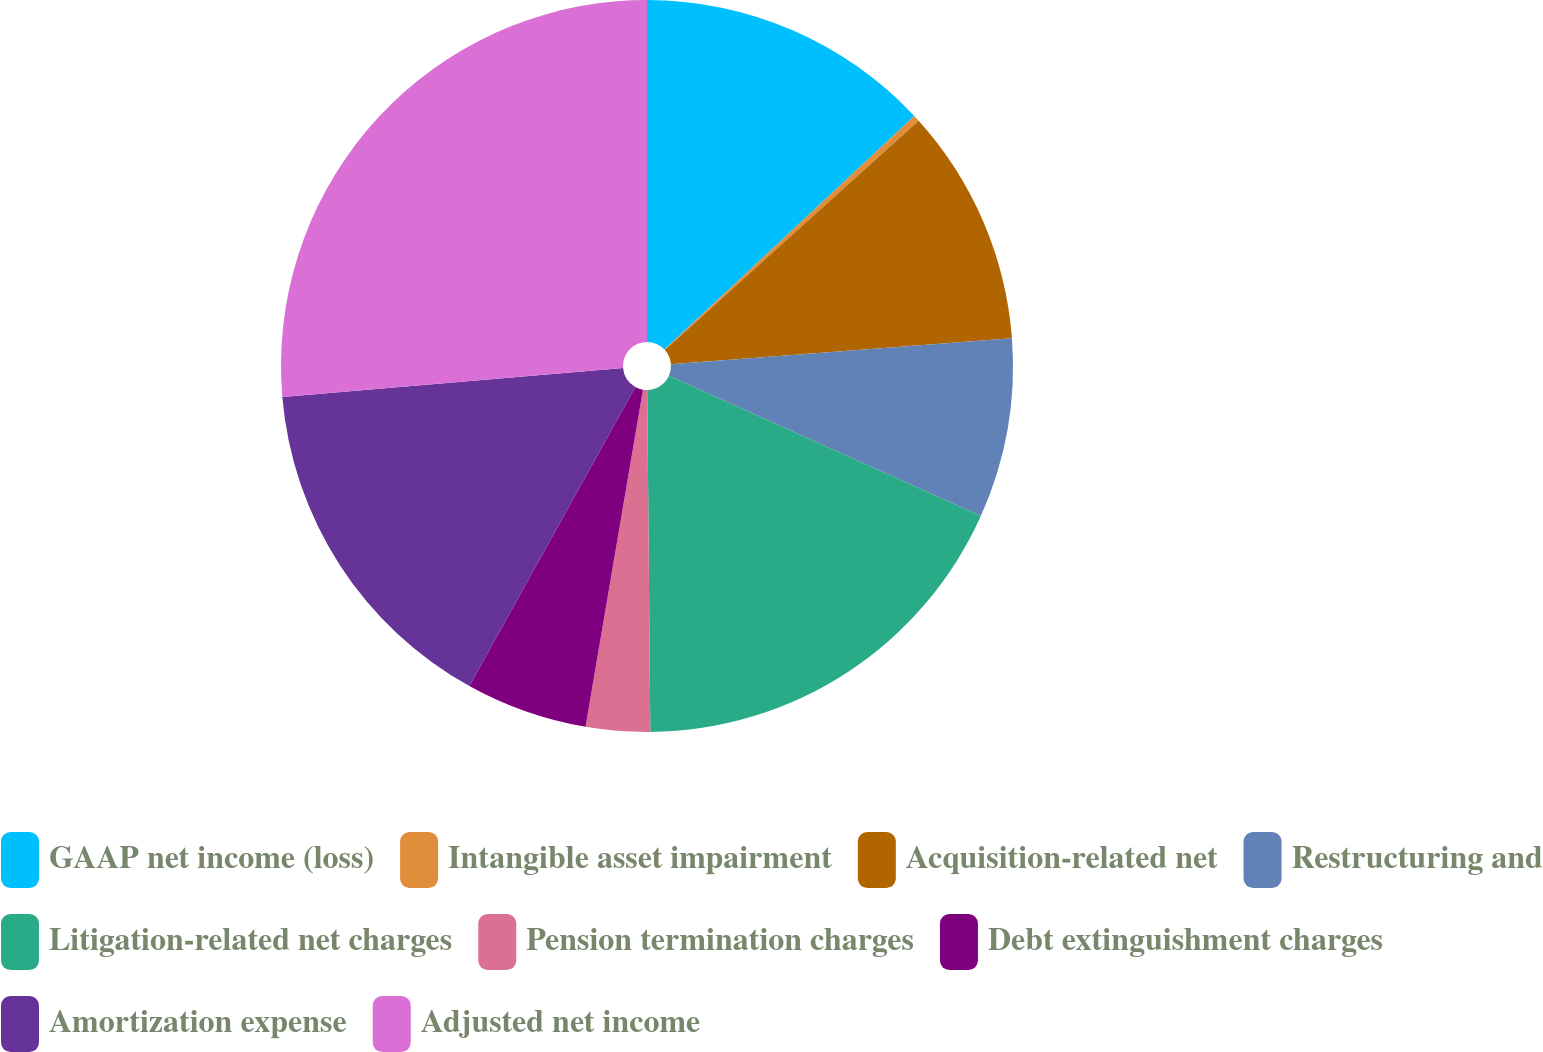Convert chart to OTSL. <chart><loc_0><loc_0><loc_500><loc_500><pie_chart><fcel>GAAP net income (loss)<fcel>Intangible asset impairment<fcel>Acquisition-related net<fcel>Restructuring and<fcel>Litigation-related net charges<fcel>Pension termination charges<fcel>Debt extinguishment charges<fcel>Amortization expense<fcel>Adjusted net income<nl><fcel>13.03%<fcel>0.28%<fcel>10.48%<fcel>7.93%<fcel>18.13%<fcel>2.83%<fcel>5.38%<fcel>15.58%<fcel>26.35%<nl></chart> 